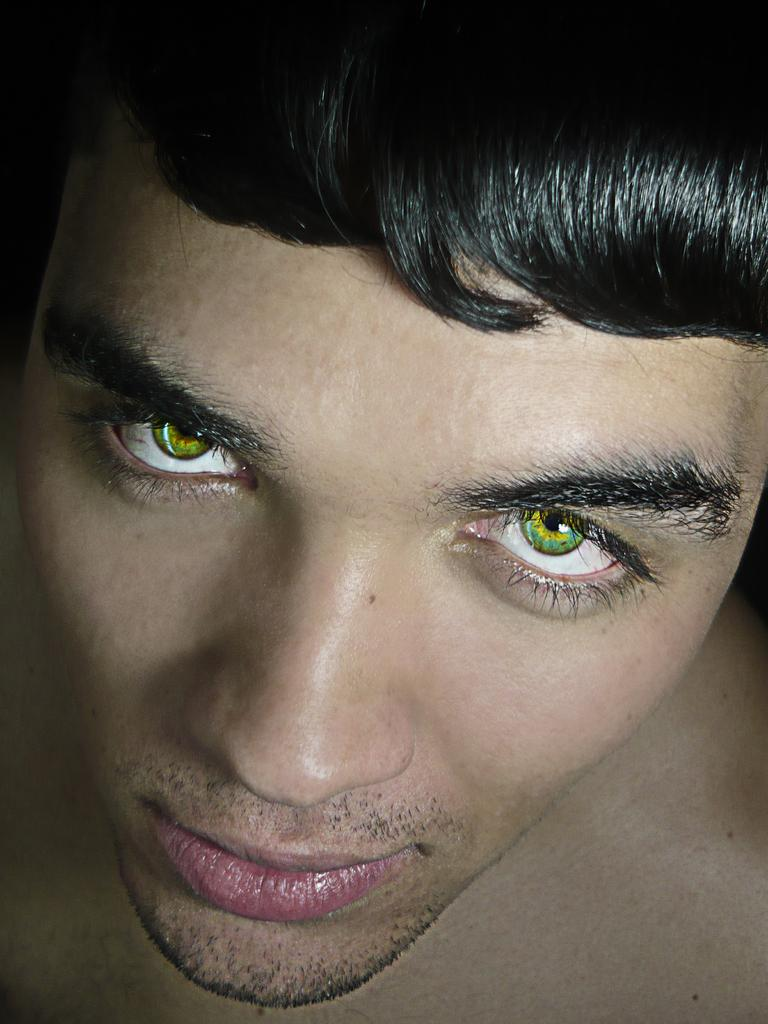What is the main subject of the image? There is a man in the image. Can you describe the man's appearance or clothing? Unfortunately, the provided facts do not include any information about the man's appearance or clothing. Is the man engaged in any activity or interacting with any objects in the image? The provided facts do not mention any activity or interaction with objects. What type of square is located downtown in the image? There is no square or downtown location mentioned in the image; the only fact provided is that there is a man in the image. 